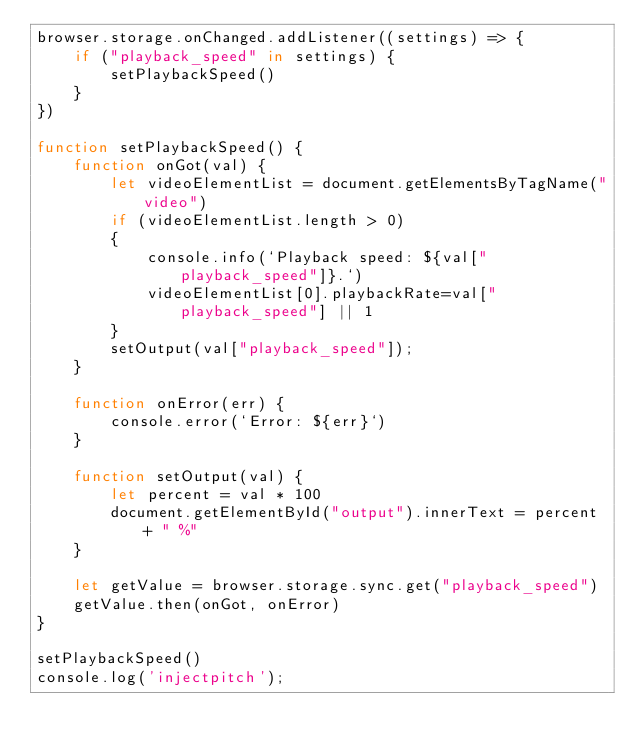Convert code to text. <code><loc_0><loc_0><loc_500><loc_500><_JavaScript_>browser.storage.onChanged.addListener((settings) => {
    if ("playback_speed" in settings) {
        setPlaybackSpeed()
    }
})

function setPlaybackSpeed() {
    function onGot(val) {        
        let videoElementList = document.getElementsByTagName("video")
        if (videoElementList.length > 0)
        {
            console.info(`Playback speed: ${val["playback_speed"]}.`)
            videoElementList[0].playbackRate=val["playback_speed"] || 1
        }
        setOutput(val["playback_speed"]);
    }

    function onError(err) {
        console.error(`Error: ${err}`)
    }

    function setOutput(val) {
        let percent = val * 100
        document.getElementById("output").innerText = percent + " %"
    }

    let getValue = browser.storage.sync.get("playback_speed")
    getValue.then(onGot, onError)
}

setPlaybackSpeed()
console.log('injectpitch');
</code> 